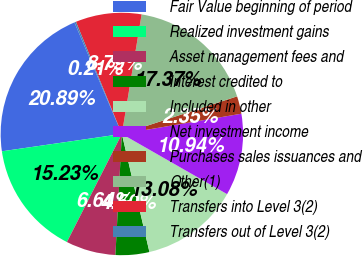Convert chart. <chart><loc_0><loc_0><loc_500><loc_500><pie_chart><fcel>Fair Value beginning of period<fcel>Realized investment gains<fcel>Asset management fees and<fcel>Interest credited to<fcel>Included in other<fcel>Net investment income<fcel>Purchases sales issuances and<fcel>Other(1)<fcel>Transfers into Level 3(2)<fcel>Transfers out of Level 3(2)<nl><fcel>20.89%<fcel>15.23%<fcel>6.64%<fcel>4.5%<fcel>13.08%<fcel>10.94%<fcel>2.35%<fcel>17.37%<fcel>8.79%<fcel>0.21%<nl></chart> 